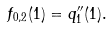<formula> <loc_0><loc_0><loc_500><loc_500>f _ { 0 , 2 } ( 1 ) = q ^ { \prime \prime } _ { 1 } ( 1 ) .</formula> 